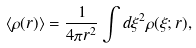<formula> <loc_0><loc_0><loc_500><loc_500>\left < \rho ( r ) \right > = \frac { 1 } { 4 \pi r ^ { 2 } } \int d \xi ^ { 2 } \rho ( \xi ; r ) ,</formula> 